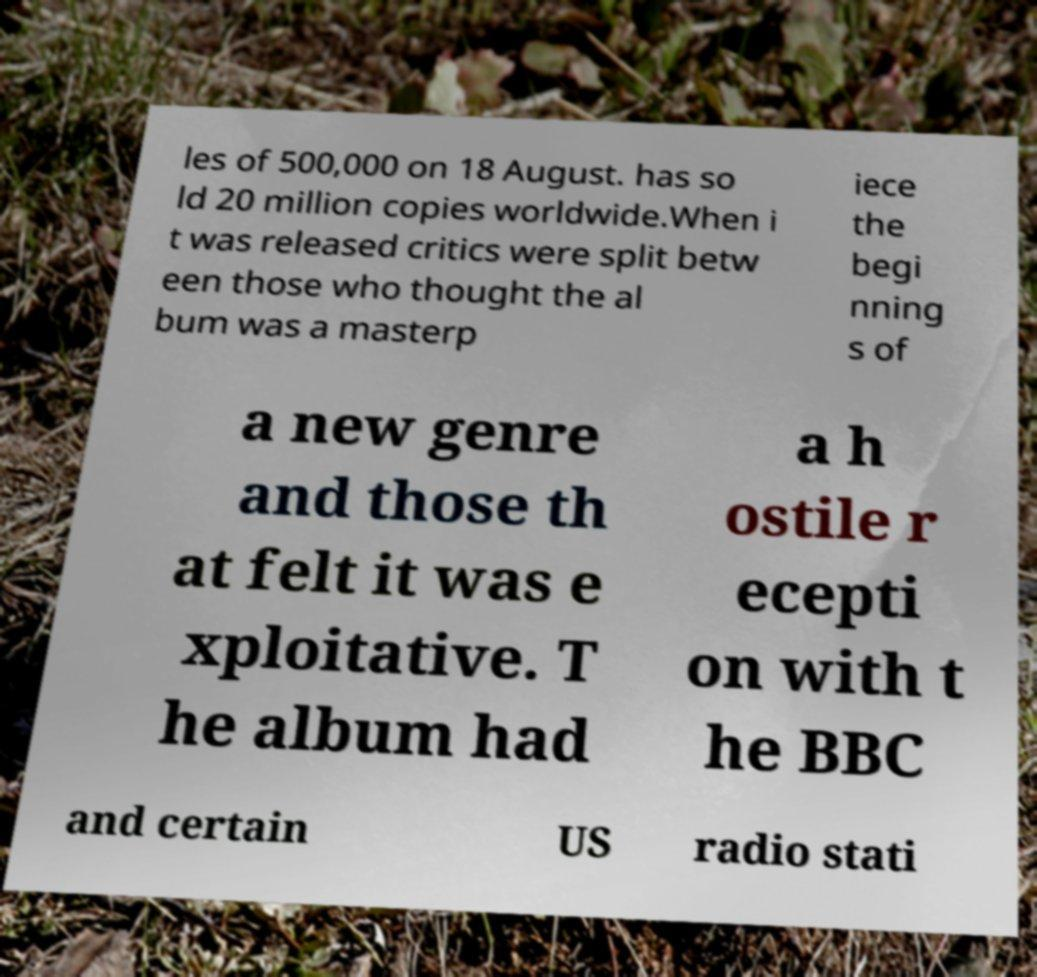I need the written content from this picture converted into text. Can you do that? les of 500,000 on 18 August. has so ld 20 million copies worldwide.When i t was released critics were split betw een those who thought the al bum was a masterp iece the begi nning s of a new genre and those th at felt it was e xploitative. T he album had a h ostile r ecepti on with t he BBC and certain US radio stati 